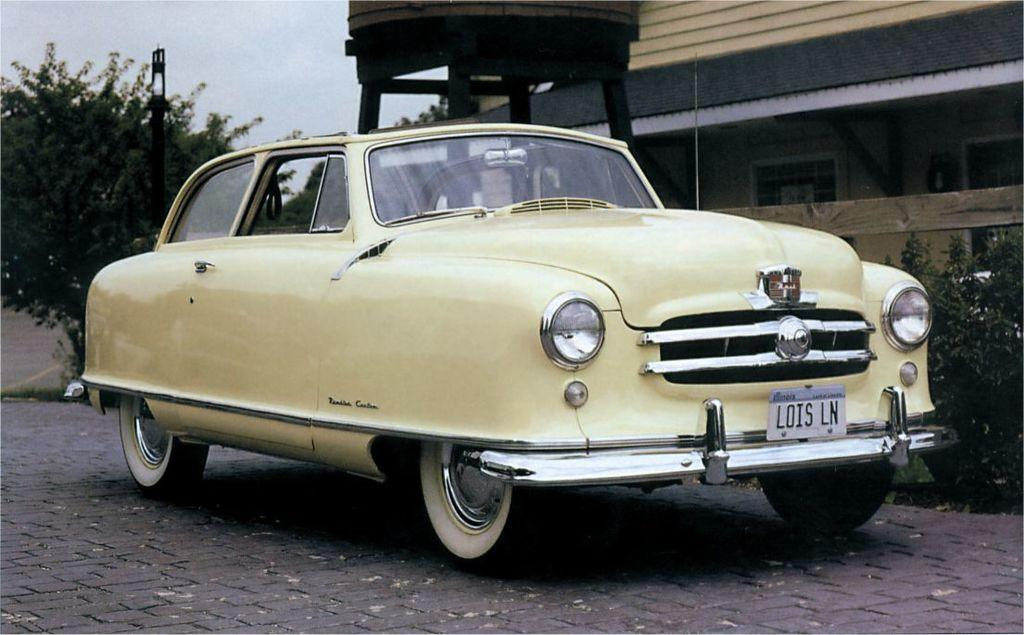What is the main subject of the image? The main subject of the image is a car. What other structures or objects can be seen in the image? There is a house, trees, and a pole in the image. How does the car attack the house in the image? The car does not attack the house in the image; it is simply parked near the house. 